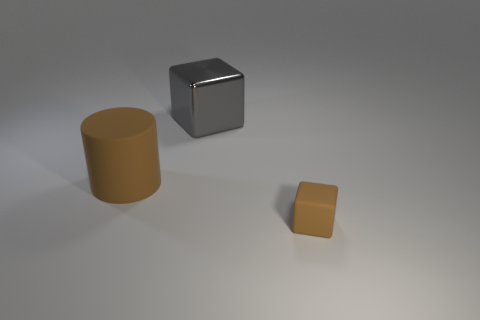Add 3 small balls. How many objects exist? 6 Subtract all blocks. How many objects are left? 1 Add 3 tiny brown objects. How many tiny brown objects are left? 4 Add 1 large cyan cylinders. How many large cyan cylinders exist? 1 Subtract 0 purple cylinders. How many objects are left? 3 Subtract all small metal things. Subtract all big shiny objects. How many objects are left? 2 